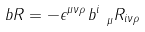<formula> <loc_0><loc_0><loc_500><loc_500>b R = - \epsilon ^ { \mu \nu \rho } \, b ^ { i } _ { \ \mu } R _ { i \nu \rho }</formula> 